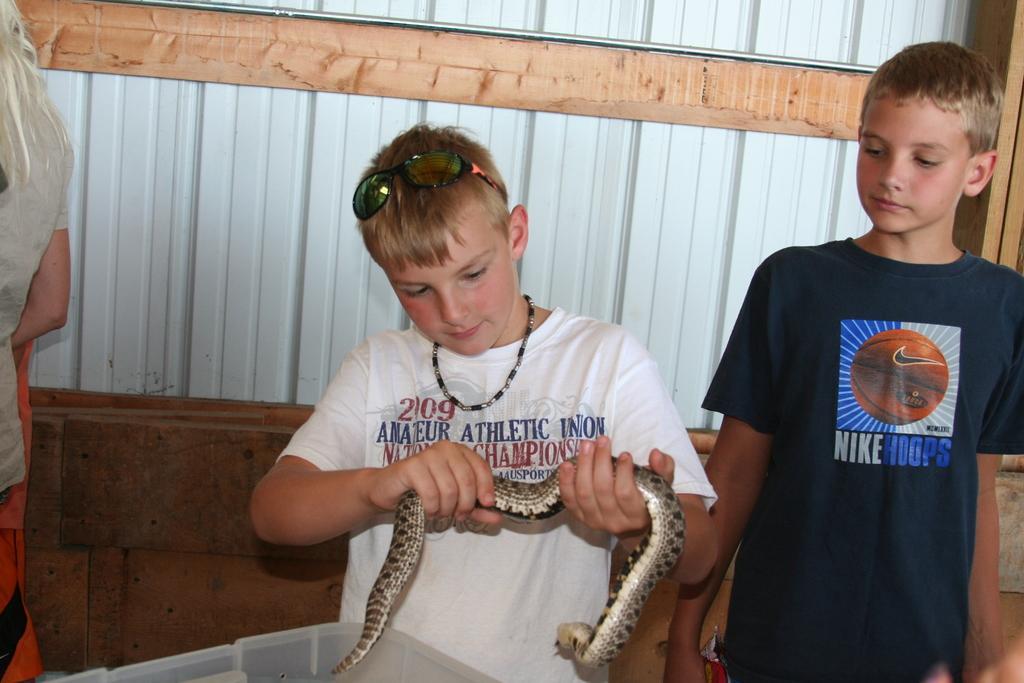Can you describe this image briefly? In this picture we can see two boys and a boy with a white t shirt who wore goggles and a chain over his neck , he is holding a snake in his hands. 